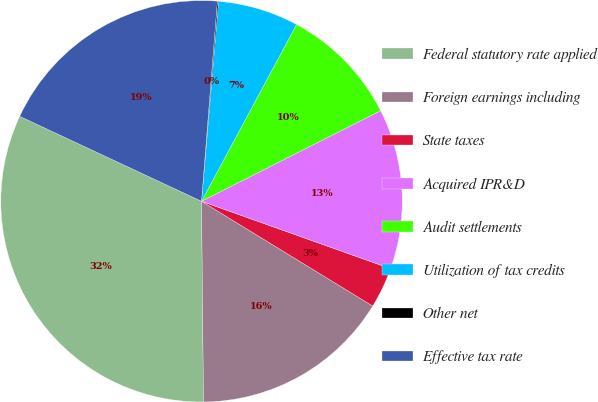Convert chart to OTSL. <chart><loc_0><loc_0><loc_500><loc_500><pie_chart><fcel>Federal statutory rate applied<fcel>Foreign earnings including<fcel>State taxes<fcel>Acquired IPR&D<fcel>Audit settlements<fcel>Utilization of tax credits<fcel>Other net<fcel>Effective tax rate<nl><fcel>32.11%<fcel>16.1%<fcel>3.29%<fcel>12.9%<fcel>9.7%<fcel>6.5%<fcel>0.09%<fcel>19.3%<nl></chart> 